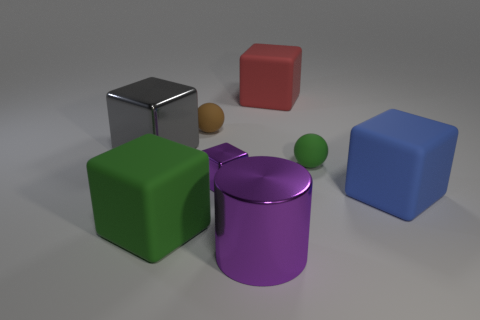What number of cylinders are either small green objects or large green rubber things?
Keep it short and to the point. 0. There is a tiny matte object behind the gray metal thing; what is its shape?
Offer a very short reply. Sphere. How many tiny cyan balls have the same material as the green ball?
Ensure brevity in your answer.  0. Is the number of large red blocks that are in front of the small shiny cube less than the number of shiny things?
Your answer should be compact. Yes. What size is the green object to the right of the small matte object that is left of the tiny block?
Provide a short and direct response. Small. There is a small metal block; does it have the same color as the big object that is right of the large red thing?
Provide a succinct answer. No. There is a green thing that is the same size as the red matte cube; what material is it?
Your response must be concise. Rubber. Is the number of small spheres in front of the small brown thing less than the number of purple metal objects left of the shiny cylinder?
Provide a succinct answer. No. What shape is the big rubber thing that is behind the ball that is in front of the large gray block?
Ensure brevity in your answer.  Cube. Are any small green matte balls visible?
Your response must be concise. Yes. 